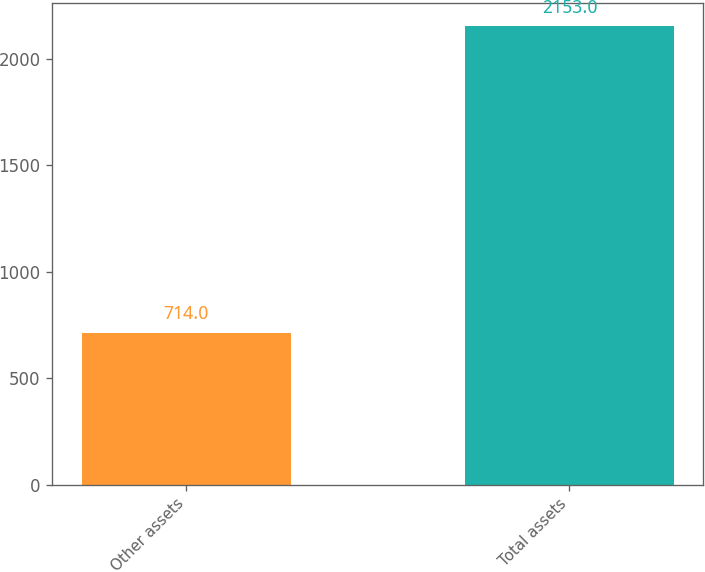Convert chart to OTSL. <chart><loc_0><loc_0><loc_500><loc_500><bar_chart><fcel>Other assets<fcel>Total assets<nl><fcel>714<fcel>2153<nl></chart> 